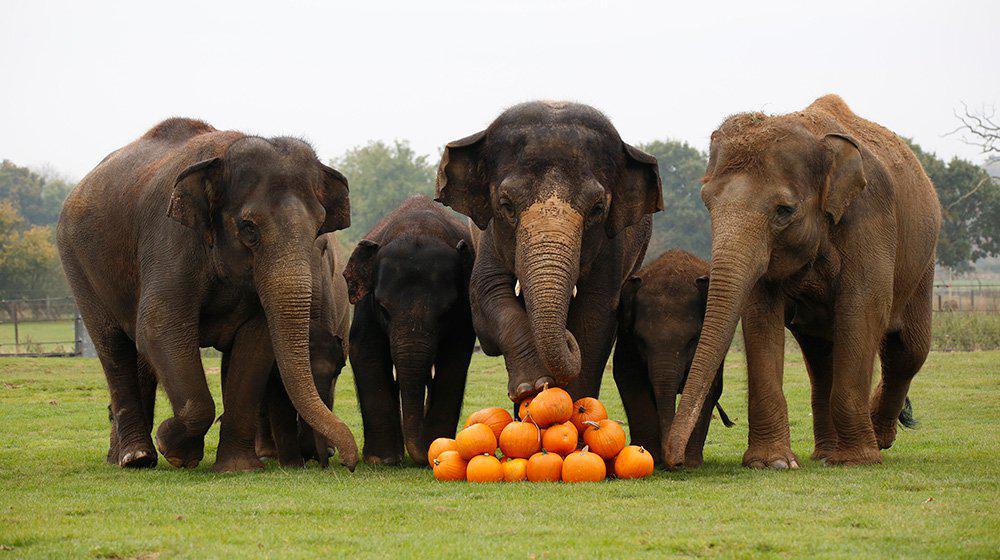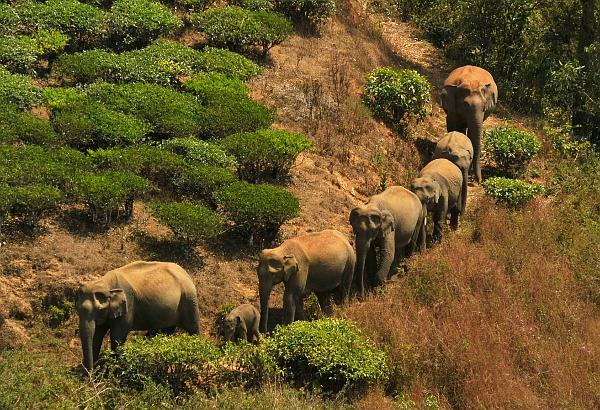The first image is the image on the left, the second image is the image on the right. For the images shown, is this caption "There are no more than three elephants in the image on the right." true? Answer yes or no. No. 